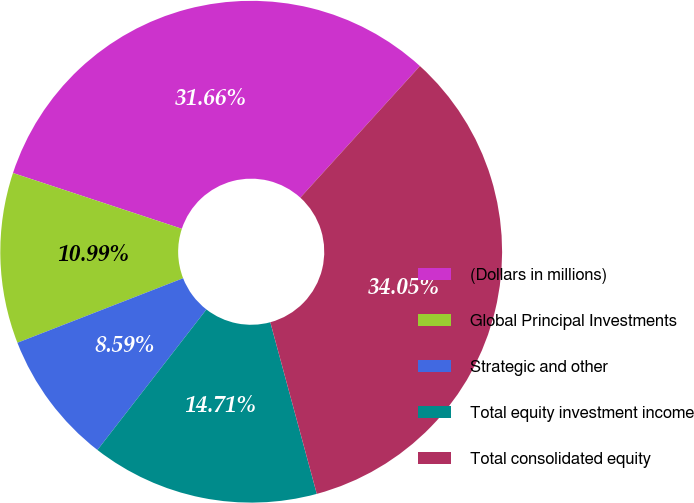Convert chart to OTSL. <chart><loc_0><loc_0><loc_500><loc_500><pie_chart><fcel>(Dollars in millions)<fcel>Global Principal Investments<fcel>Strategic and other<fcel>Total equity investment income<fcel>Total consolidated equity<nl><fcel>31.66%<fcel>10.99%<fcel>8.59%<fcel>14.71%<fcel>34.05%<nl></chart> 